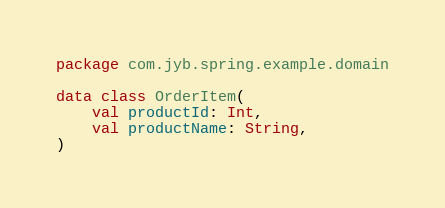Convert code to text. <code><loc_0><loc_0><loc_500><loc_500><_Kotlin_>package com.jyb.spring.example.domain

data class OrderItem(
    val productId: Int,
    val productName: String,
)</code> 